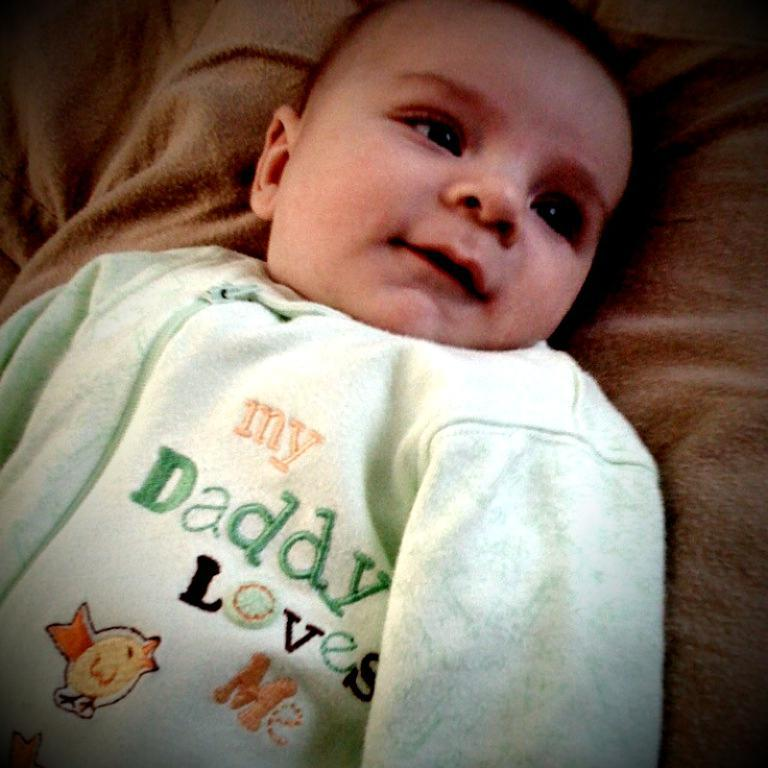What is the main subject of the image? The main subject of the image is a kid. What is the kid doing in the image? The kid is lying on a cloth. What type of mint can be seen growing near the kid in the image? There is no mint present in the image; it only features a kid lying on a cloth. 